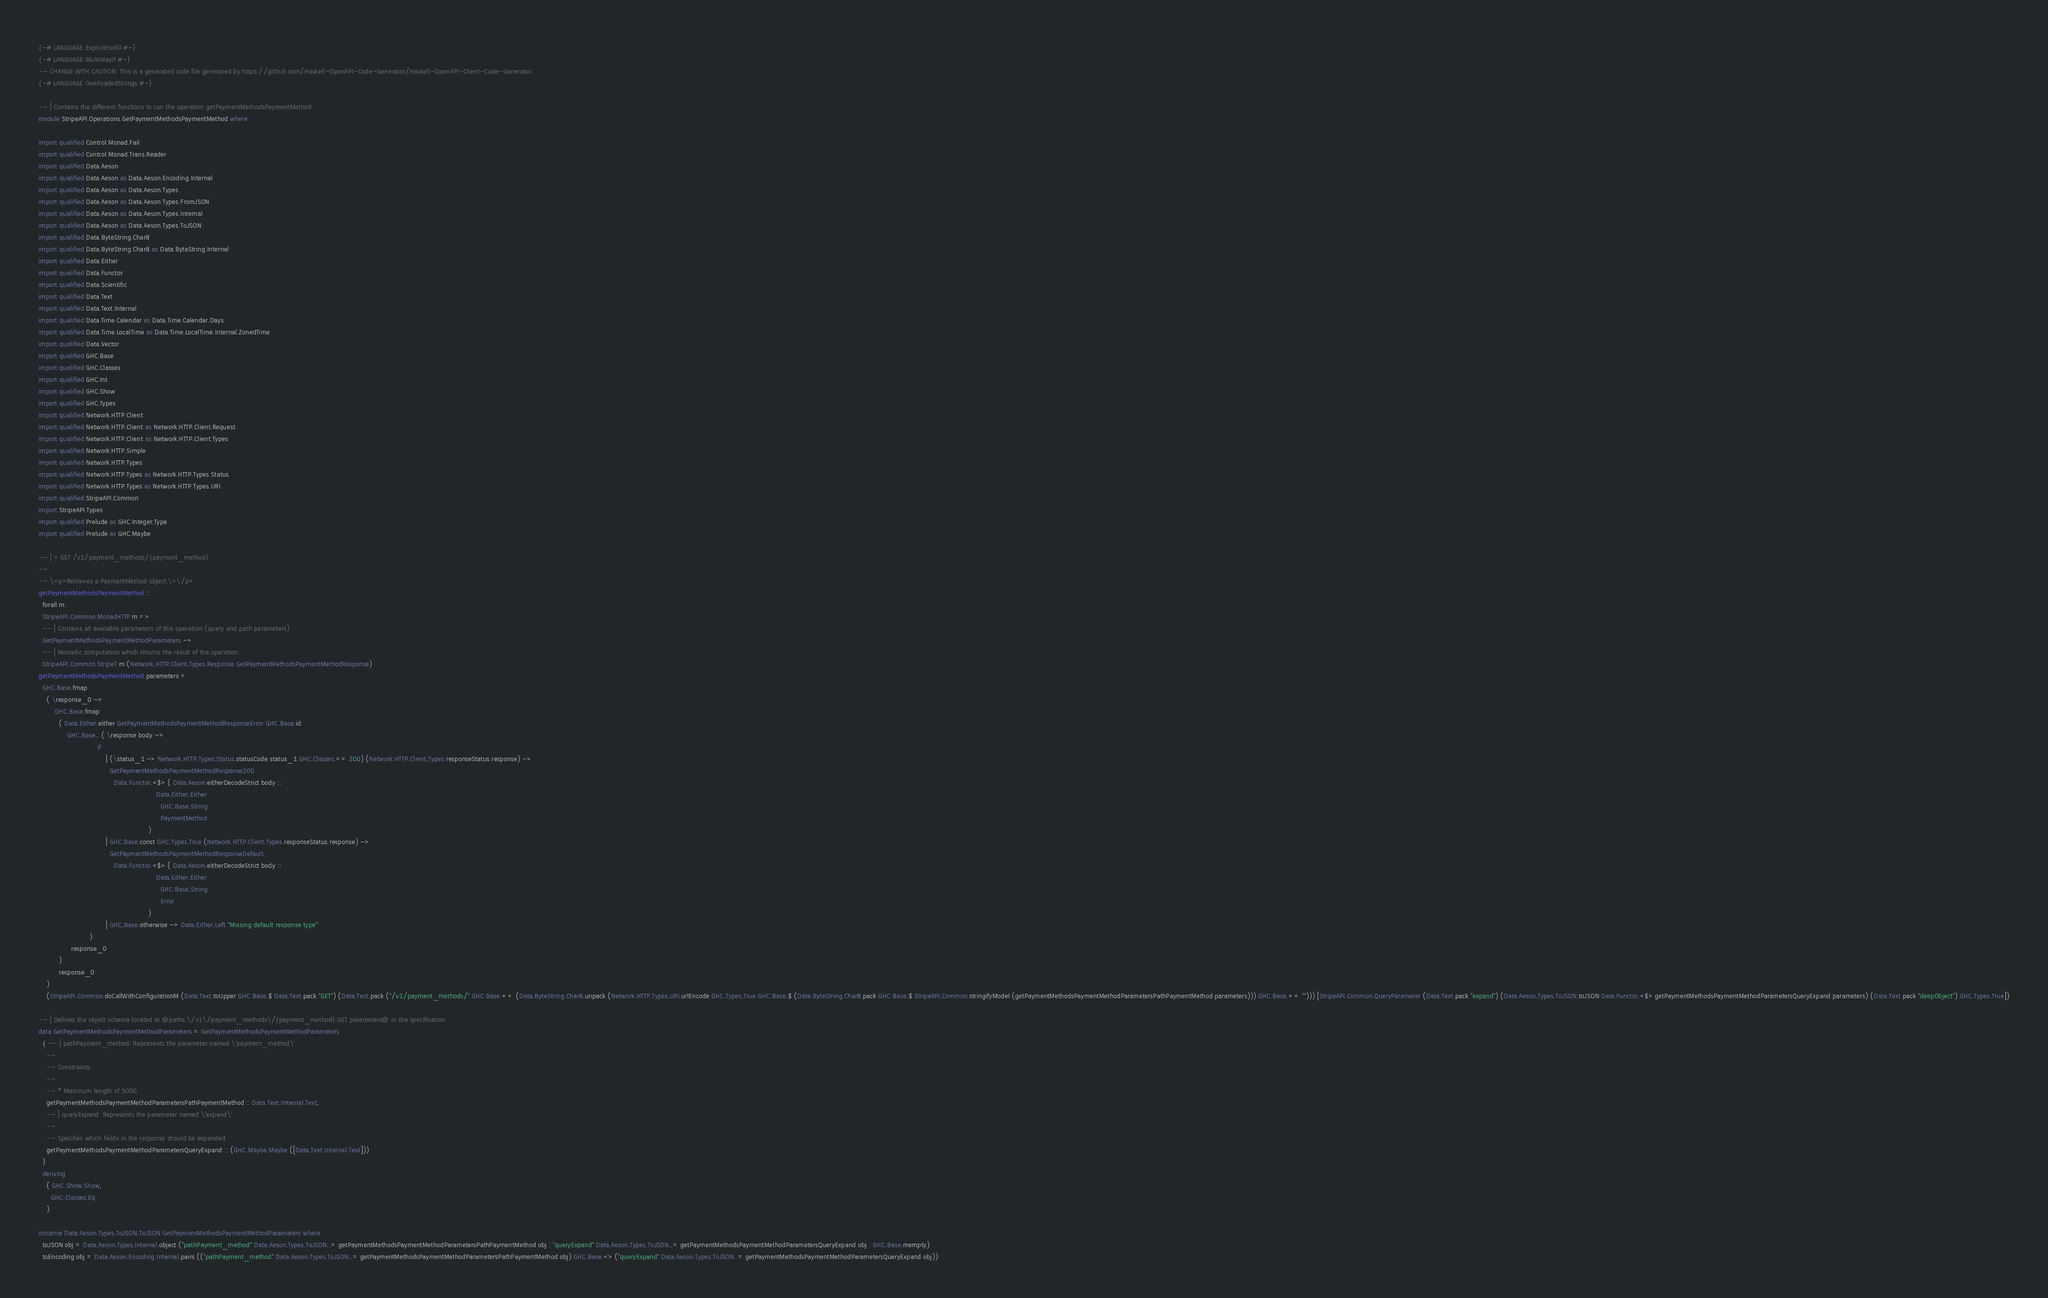<code> <loc_0><loc_0><loc_500><loc_500><_Haskell_>{-# LANGUAGE ExplicitForAll #-}
{-# LANGUAGE MultiWayIf #-}
-- CHANGE WITH CAUTION: This is a generated code file generated by https://github.com/Haskell-OpenAPI-Code-Generator/Haskell-OpenAPI-Client-Code-Generator.
{-# LANGUAGE OverloadedStrings #-}

-- | Contains the different functions to run the operation getPaymentMethodsPaymentMethod
module StripeAPI.Operations.GetPaymentMethodsPaymentMethod where

import qualified Control.Monad.Fail
import qualified Control.Monad.Trans.Reader
import qualified Data.Aeson
import qualified Data.Aeson as Data.Aeson.Encoding.Internal
import qualified Data.Aeson as Data.Aeson.Types
import qualified Data.Aeson as Data.Aeson.Types.FromJSON
import qualified Data.Aeson as Data.Aeson.Types.Internal
import qualified Data.Aeson as Data.Aeson.Types.ToJSON
import qualified Data.ByteString.Char8
import qualified Data.ByteString.Char8 as Data.ByteString.Internal
import qualified Data.Either
import qualified Data.Functor
import qualified Data.Scientific
import qualified Data.Text
import qualified Data.Text.Internal
import qualified Data.Time.Calendar as Data.Time.Calendar.Days
import qualified Data.Time.LocalTime as Data.Time.LocalTime.Internal.ZonedTime
import qualified Data.Vector
import qualified GHC.Base
import qualified GHC.Classes
import qualified GHC.Int
import qualified GHC.Show
import qualified GHC.Types
import qualified Network.HTTP.Client
import qualified Network.HTTP.Client as Network.HTTP.Client.Request
import qualified Network.HTTP.Client as Network.HTTP.Client.Types
import qualified Network.HTTP.Simple
import qualified Network.HTTP.Types
import qualified Network.HTTP.Types as Network.HTTP.Types.Status
import qualified Network.HTTP.Types as Network.HTTP.Types.URI
import qualified StripeAPI.Common
import StripeAPI.Types
import qualified Prelude as GHC.Integer.Type
import qualified Prelude as GHC.Maybe

-- | > GET /v1/payment_methods/{payment_method}
--
-- \<p>Retrieves a PaymentMethod object.\<\/p>
getPaymentMethodsPaymentMethod ::
  forall m.
  StripeAPI.Common.MonadHTTP m =>
  -- | Contains all available parameters of this operation (query and path parameters)
  GetPaymentMethodsPaymentMethodParameters ->
  -- | Monadic computation which returns the result of the operation
  StripeAPI.Common.StripeT m (Network.HTTP.Client.Types.Response GetPaymentMethodsPaymentMethodResponse)
getPaymentMethodsPaymentMethod parameters =
  GHC.Base.fmap
    ( \response_0 ->
        GHC.Base.fmap
          ( Data.Either.either GetPaymentMethodsPaymentMethodResponseError GHC.Base.id
              GHC.Base.. ( \response body ->
                             if
                                 | (\status_1 -> Network.HTTP.Types.Status.statusCode status_1 GHC.Classes.== 200) (Network.HTTP.Client.Types.responseStatus response) ->
                                   GetPaymentMethodsPaymentMethodResponse200
                                     Data.Functor.<$> ( Data.Aeson.eitherDecodeStrict body ::
                                                          Data.Either.Either
                                                            GHC.Base.String
                                                            PaymentMethod
                                                      )
                                 | GHC.Base.const GHC.Types.True (Network.HTTP.Client.Types.responseStatus response) ->
                                   GetPaymentMethodsPaymentMethodResponseDefault
                                     Data.Functor.<$> ( Data.Aeson.eitherDecodeStrict body ::
                                                          Data.Either.Either
                                                            GHC.Base.String
                                                            Error
                                                      )
                                 | GHC.Base.otherwise -> Data.Either.Left "Missing default response type"
                         )
                response_0
          )
          response_0
    )
    (StripeAPI.Common.doCallWithConfigurationM (Data.Text.toUpper GHC.Base.$ Data.Text.pack "GET") (Data.Text.pack ("/v1/payment_methods/" GHC.Base.++ (Data.ByteString.Char8.unpack (Network.HTTP.Types.URI.urlEncode GHC.Types.True GHC.Base.$ (Data.ByteString.Char8.pack GHC.Base.$ StripeAPI.Common.stringifyModel (getPaymentMethodsPaymentMethodParametersPathPaymentMethod parameters))) GHC.Base.++ ""))) [StripeAPI.Common.QueryParameter (Data.Text.pack "expand") (Data.Aeson.Types.ToJSON.toJSON Data.Functor.<$> getPaymentMethodsPaymentMethodParametersQueryExpand parameters) (Data.Text.pack "deepObject") GHC.Types.True])

-- | Defines the object schema located at @paths.\/v1\/payment_methods\/{payment_method}.GET.parameters@ in the specification.
data GetPaymentMethodsPaymentMethodParameters = GetPaymentMethodsPaymentMethodParameters
  { -- | pathPayment_method: Represents the parameter named \'payment_method\'
    --
    -- Constraints:
    --
    -- * Maximum length of 5000
    getPaymentMethodsPaymentMethodParametersPathPaymentMethod :: Data.Text.Internal.Text,
    -- | queryExpand: Represents the parameter named \'expand\'
    --
    -- Specifies which fields in the response should be expanded.
    getPaymentMethodsPaymentMethodParametersQueryExpand :: (GHC.Maybe.Maybe ([Data.Text.Internal.Text]))
  }
  deriving
    ( GHC.Show.Show,
      GHC.Classes.Eq
    )

instance Data.Aeson.Types.ToJSON.ToJSON GetPaymentMethodsPaymentMethodParameters where
  toJSON obj = Data.Aeson.Types.Internal.object ("pathPayment_method" Data.Aeson.Types.ToJSON..= getPaymentMethodsPaymentMethodParametersPathPaymentMethod obj : "queryExpand" Data.Aeson.Types.ToJSON..= getPaymentMethodsPaymentMethodParametersQueryExpand obj : GHC.Base.mempty)
  toEncoding obj = Data.Aeson.Encoding.Internal.pairs (("pathPayment_method" Data.Aeson.Types.ToJSON..= getPaymentMethodsPaymentMethodParametersPathPaymentMethod obj) GHC.Base.<> ("queryExpand" Data.Aeson.Types.ToJSON..= getPaymentMethodsPaymentMethodParametersQueryExpand obj))
</code> 